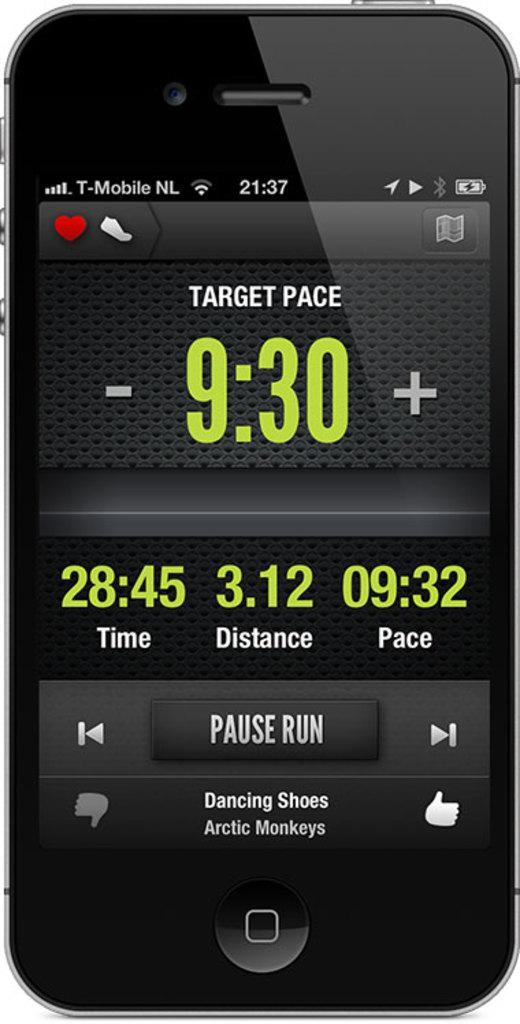Provide a one-sentence caption for the provided image. Phone with a tracking app with target pace set at 9:30. 